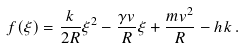<formula> <loc_0><loc_0><loc_500><loc_500>f ( \xi ) = \frac { k } { 2 R } \xi ^ { 2 } - \frac { \gamma v } { R } \xi + \frac { m v ^ { 2 } } { R } - h k \, .</formula> 